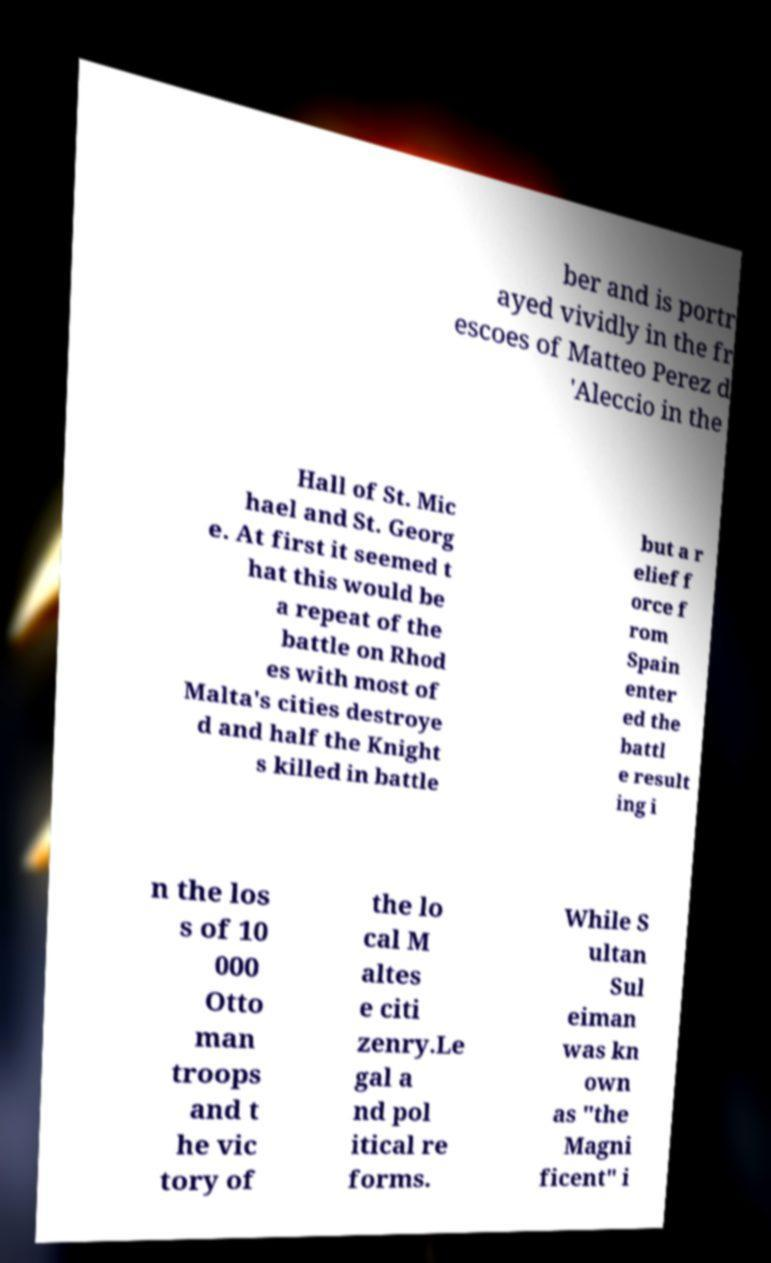What messages or text are displayed in this image? I need them in a readable, typed format. ber and is portr ayed vividly in the fr escoes of Matteo Perez d 'Aleccio in the Hall of St. Mic hael and St. Georg e. At first it seemed t hat this would be a repeat of the battle on Rhod es with most of Malta's cities destroye d and half the Knight s killed in battle but a r elief f orce f rom Spain enter ed the battl e result ing i n the los s of 10 000 Otto man troops and t he vic tory of the lo cal M altes e citi zenry.Le gal a nd pol itical re forms. While S ultan Sul eiman was kn own as "the Magni ficent" i 